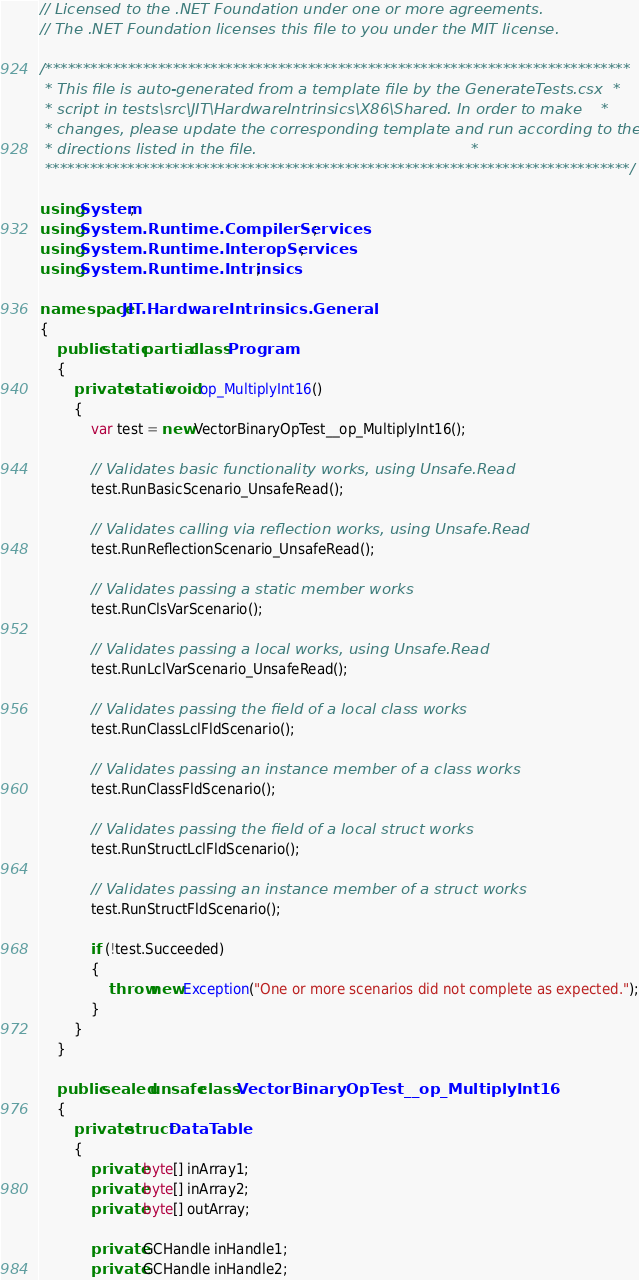Convert code to text. <code><loc_0><loc_0><loc_500><loc_500><_C#_>// Licensed to the .NET Foundation under one or more agreements.
// The .NET Foundation licenses this file to you under the MIT license.

/******************************************************************************
 * This file is auto-generated from a template file by the GenerateTests.csx  *
 * script in tests\src\JIT\HardwareIntrinsics\X86\Shared. In order to make    *
 * changes, please update the corresponding template and run according to the *
 * directions listed in the file.                                             *
 ******************************************************************************/

using System;
using System.Runtime.CompilerServices;
using System.Runtime.InteropServices;
using System.Runtime.Intrinsics;

namespace JIT.HardwareIntrinsics.General
{
    public static partial class Program
    {
        private static void op_MultiplyInt16()
        {
            var test = new VectorBinaryOpTest__op_MultiplyInt16();

            // Validates basic functionality works, using Unsafe.Read
            test.RunBasicScenario_UnsafeRead();

            // Validates calling via reflection works, using Unsafe.Read
            test.RunReflectionScenario_UnsafeRead();

            // Validates passing a static member works
            test.RunClsVarScenario();

            // Validates passing a local works, using Unsafe.Read
            test.RunLclVarScenario_UnsafeRead();

            // Validates passing the field of a local class works
            test.RunClassLclFldScenario();

            // Validates passing an instance member of a class works
            test.RunClassFldScenario();

            // Validates passing the field of a local struct works
            test.RunStructLclFldScenario();

            // Validates passing an instance member of a struct works
            test.RunStructFldScenario();

            if (!test.Succeeded)
            {
                throw new Exception("One or more scenarios did not complete as expected.");
            }
        }
    }

    public sealed unsafe class VectorBinaryOpTest__op_MultiplyInt16
    {
        private struct DataTable
        {
            private byte[] inArray1;
            private byte[] inArray2;
            private byte[] outArray;

            private GCHandle inHandle1;
            private GCHandle inHandle2;</code> 